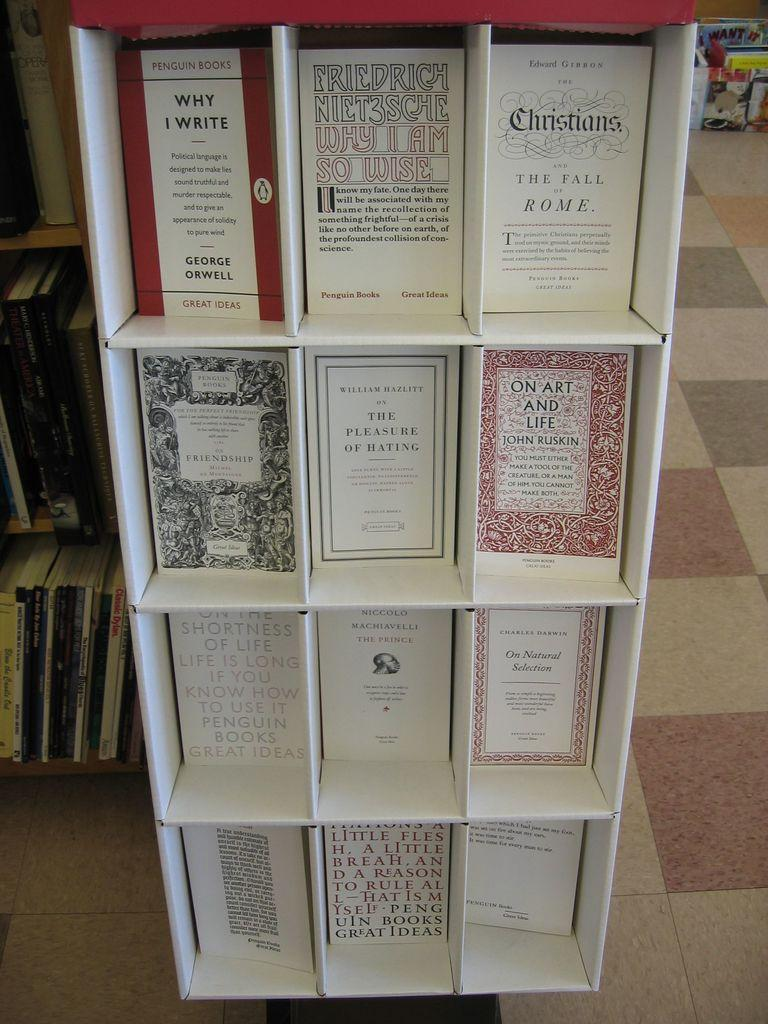Provide a one-sentence caption for the provided image. A cardboard shelf holding various authors Penguin Books. 